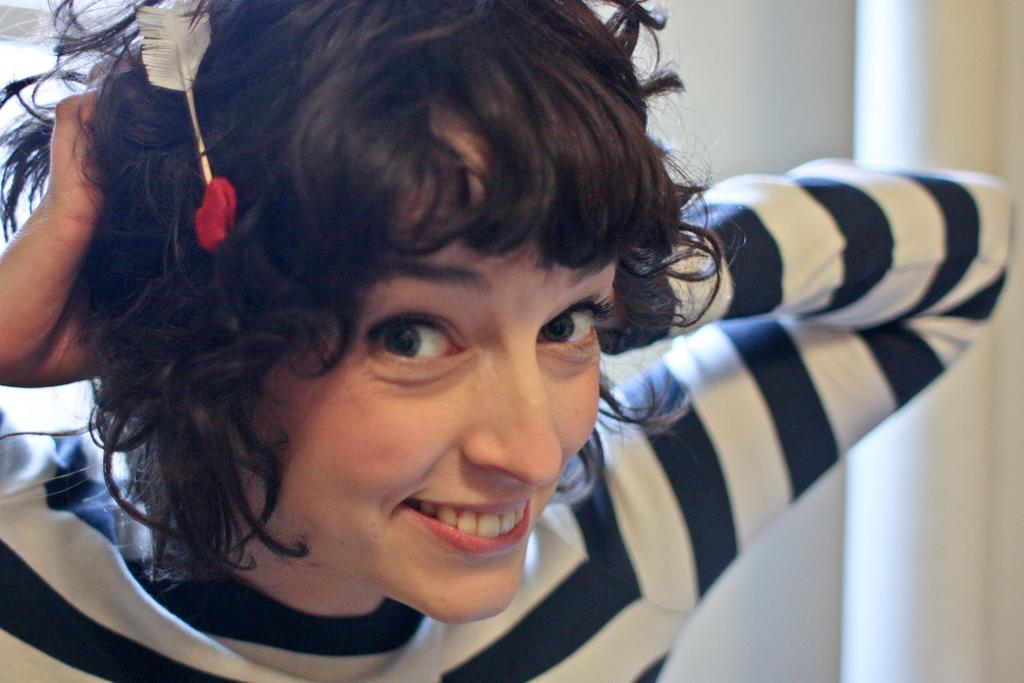Who is present in the image? There is a woman in the image. What is the woman's facial expression? The woman is smiling. What is on the woman's head? There is an object on the woman's head. What can be seen in the background of the image? There is a curtain in the background of the image. What color is the curtain? The curtain is white in color. What type of silk material is used for the woman's suit in the image? There is no suit present in the image, and silk is not mentioned in the provided facts. 